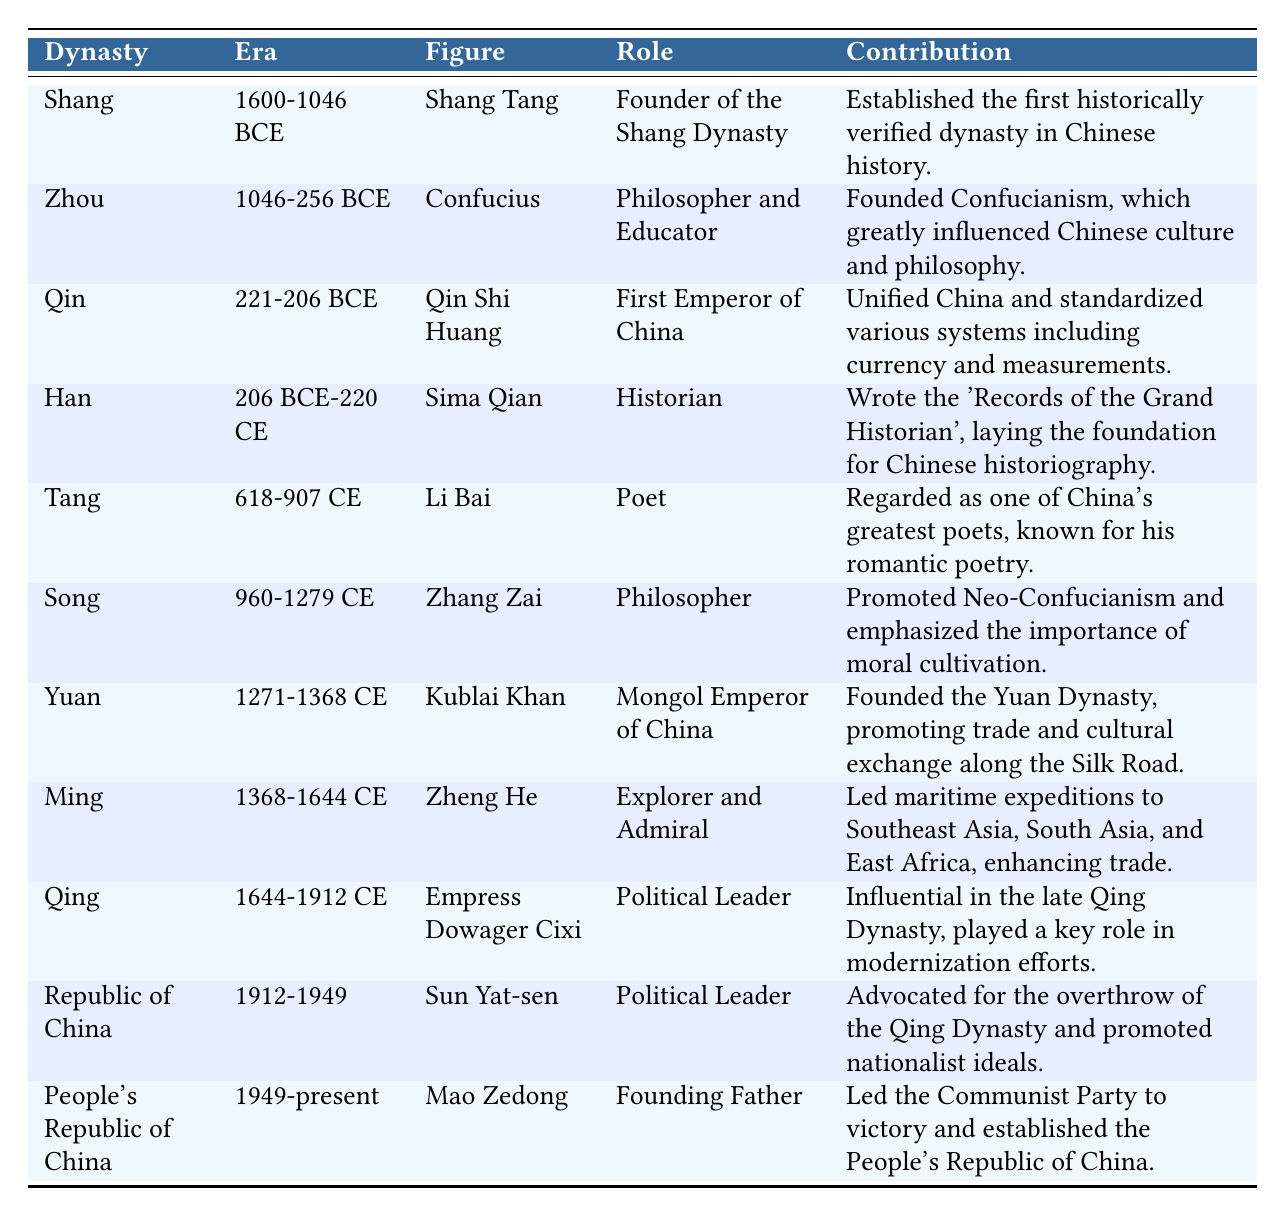What dynasty did Confucius belong to? Confucius is listed under the Zhou dynasty in the table. Therefore, he belonged to the Zhou dynasty.
Answer: Zhou Who is recognized as the first emperor of China? The table identifies Qin Shi Huang as the first emperor of China under the Qin dynasty.
Answer: Qin Shi Huang What contribution did Sima Qian make to Chinese historiography? Sima Qian is noted for writing the 'Records of the Grand Historian', which is a foundational work in Chinese historiography.
Answer: 'Records of the Grand Historian' Which figure from the Ming dynasty was known for maritime expeditions? The table states that Zheng He was an explorer and admiral known for his maritime expeditions during the Ming dynasty.
Answer: Zheng He Is Empress Dowager Cixi associated with the Qing dynasty? The table shows that Empress Dowager Cixi is indeed associated with the Qing dynasty and is marked as a political leader.
Answer: Yes How many dynasties are represented in this table? The table lists figures from 11 distinct dynasties, which are Shang, Zhou, Qin, Han, Tang, Song, Yuan, Ming, Qing, Republic of China, and People's Republic of China.
Answer: 11 Which figure from the Song dynasty promoted Neo-Confucianism? According to the table, Zhang Zai from the Song dynasty is credited with promoting Neo-Confucianism.
Answer: Zhang Zai Did Kublai Khan influence trade and cultural exchange in China? The table states that Kublai Khan founded the Yuan Dynasty and promoted trade and cultural exchange along the Silk Road, indicating a positive influence.
Answer: Yes What was the role of Mao Zedong during the People's Republic of China era? The table attributes the role of founding father to Mao Zedong during the era of the People's Republic of China.
Answer: Founding Father Which figure was a political leader before the People's Republic of China and what were his contributions? Before Mao Zedong, Sun Yat-sen was a political leader during the Republic of China era, advocating for the overthrow of the Qing Dynasty and promoting nationalist ideals.
Answer: Sun Yat-sen, overthrowing Qing Dynasty and promoting nationalism How does the role of Li Bai as a poet compare to the contributions of other figures listed? Li Bai is recognized for being one of China's greatest poets and is dedicated to romantic poetry, which is distinct from other figures whose contributions are more political or philosophical in nature, indicating a focus on cultural over political influence.
Answer: Cultural influence through poetry 